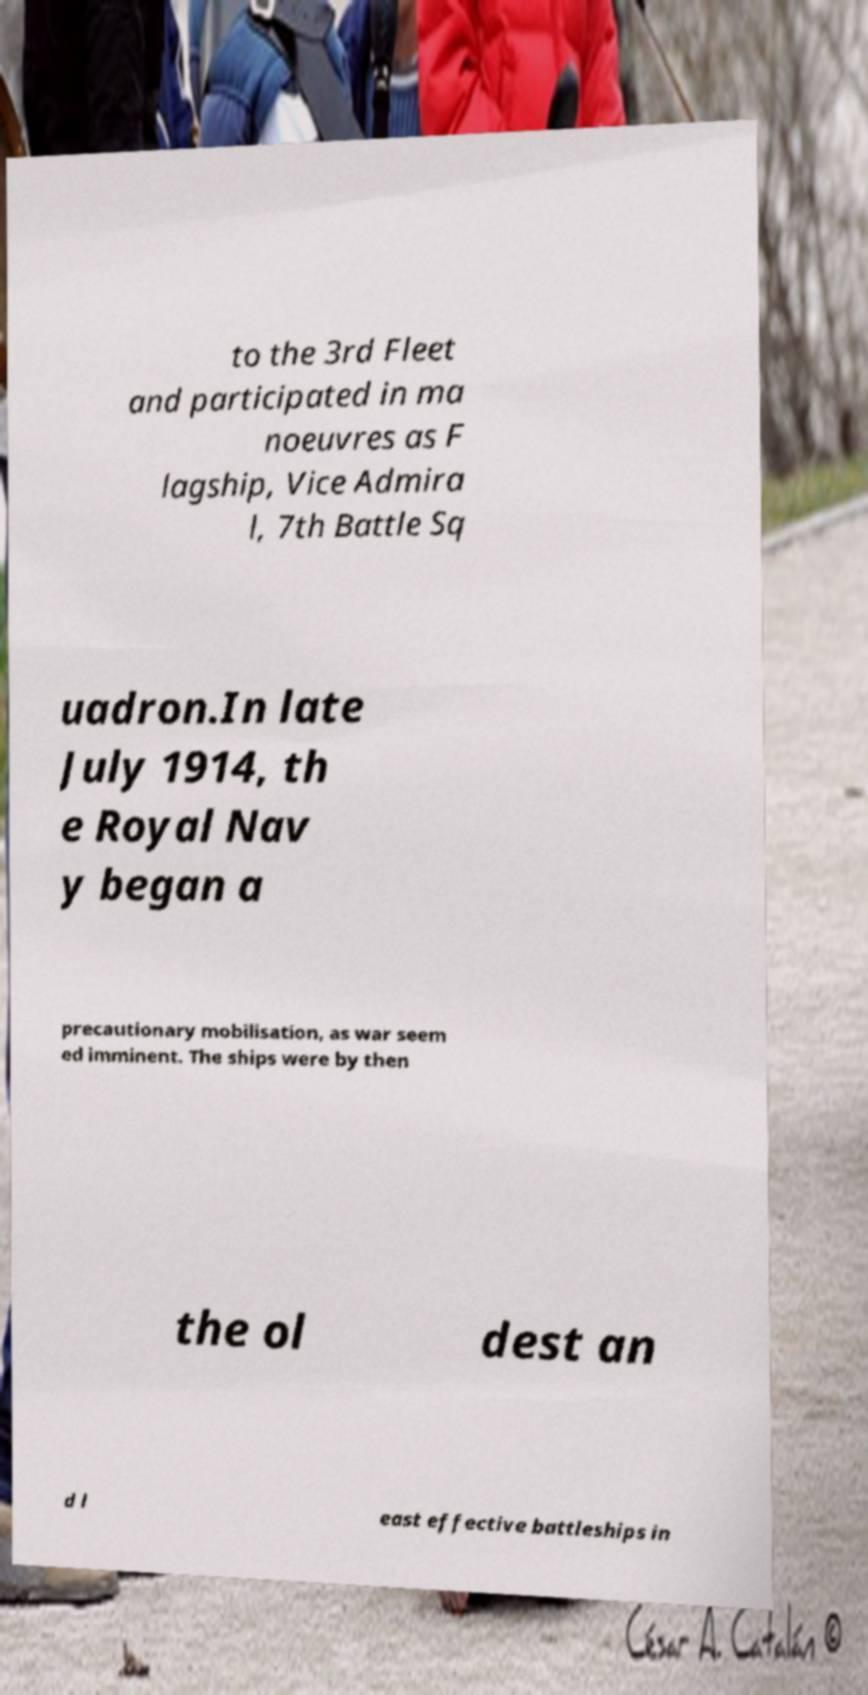I need the written content from this picture converted into text. Can you do that? to the 3rd Fleet and participated in ma noeuvres as F lagship, Vice Admira l, 7th Battle Sq uadron.In late July 1914, th e Royal Nav y began a precautionary mobilisation, as war seem ed imminent. The ships were by then the ol dest an d l east effective battleships in 